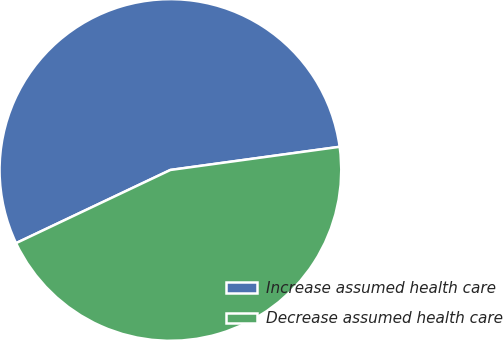<chart> <loc_0><loc_0><loc_500><loc_500><pie_chart><fcel>Increase assumed health care<fcel>Decrease assumed health care<nl><fcel>54.88%<fcel>45.12%<nl></chart> 